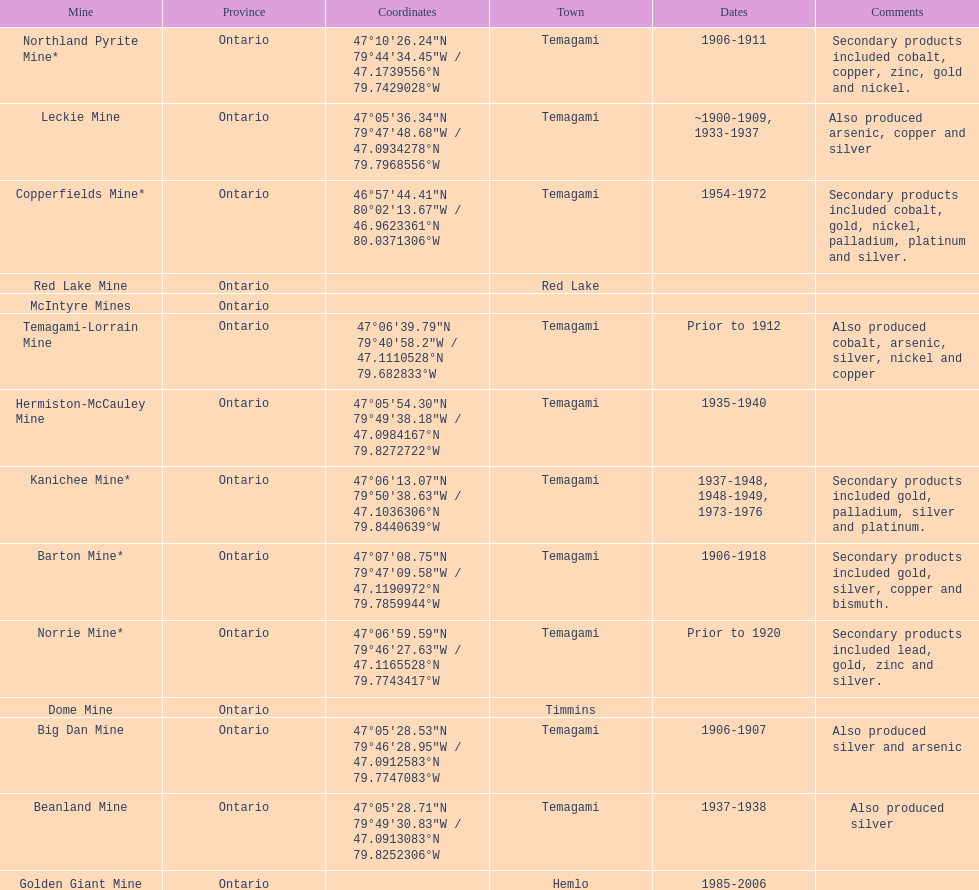Which mine was open longer, golden giant or beanland mine? Golden Giant Mine. 